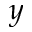Convert formula to latex. <formula><loc_0><loc_0><loc_500><loc_500>y</formula> 